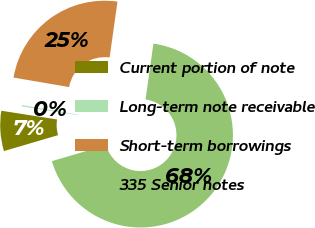Convert chart to OTSL. <chart><loc_0><loc_0><loc_500><loc_500><pie_chart><fcel>Current portion of note<fcel>Long-term note receivable<fcel>Short-term borrowings<fcel>335 Senior notes<nl><fcel>7.02%<fcel>0.22%<fcel>24.54%<fcel>68.22%<nl></chart> 